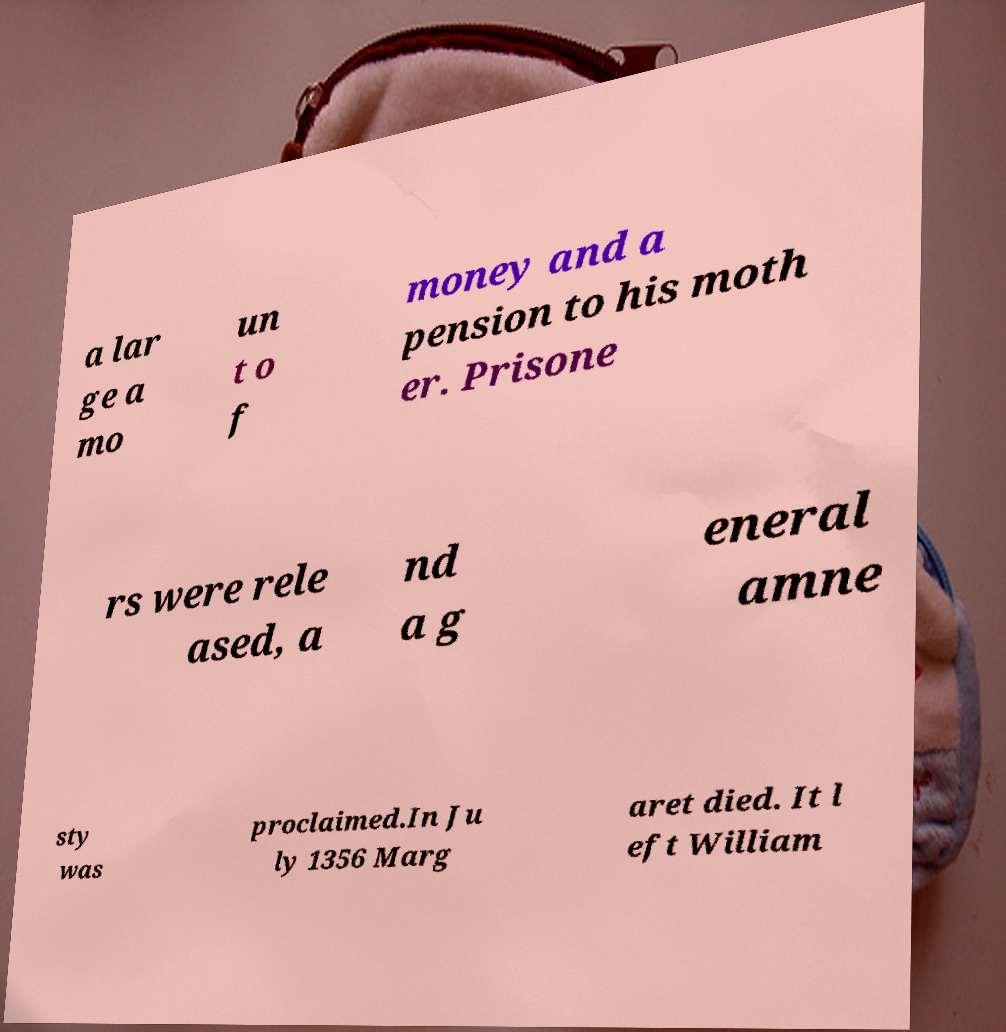Can you read and provide the text displayed in the image?This photo seems to have some interesting text. Can you extract and type it out for me? a lar ge a mo un t o f money and a pension to his moth er. Prisone rs were rele ased, a nd a g eneral amne sty was proclaimed.In Ju ly 1356 Marg aret died. It l eft William 